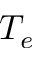Convert formula to latex. <formula><loc_0><loc_0><loc_500><loc_500>T _ { e }</formula> 